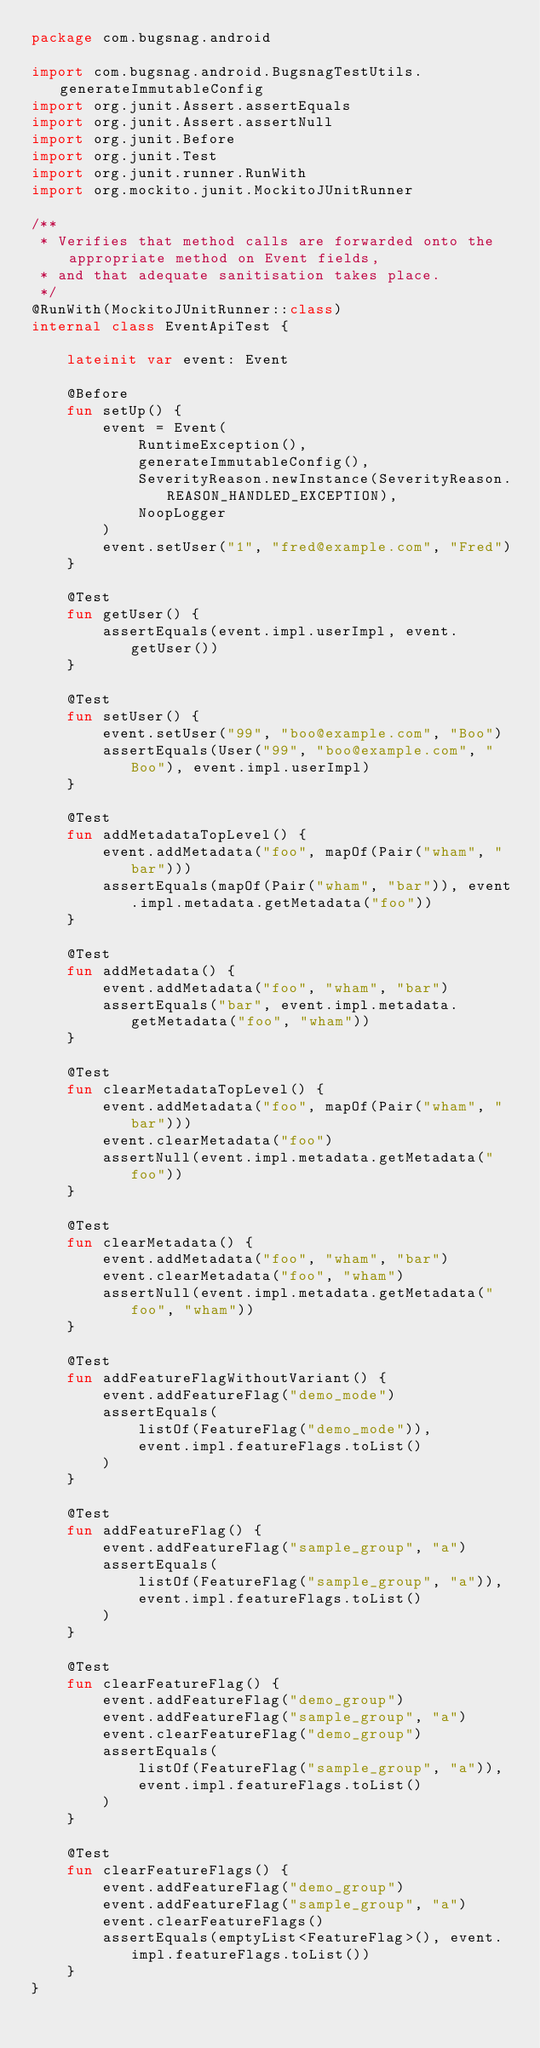<code> <loc_0><loc_0><loc_500><loc_500><_Kotlin_>package com.bugsnag.android

import com.bugsnag.android.BugsnagTestUtils.generateImmutableConfig
import org.junit.Assert.assertEquals
import org.junit.Assert.assertNull
import org.junit.Before
import org.junit.Test
import org.junit.runner.RunWith
import org.mockito.junit.MockitoJUnitRunner

/**
 * Verifies that method calls are forwarded onto the appropriate method on Event fields,
 * and that adequate sanitisation takes place.
 */
@RunWith(MockitoJUnitRunner::class)
internal class EventApiTest {

    lateinit var event: Event

    @Before
    fun setUp() {
        event = Event(
            RuntimeException(),
            generateImmutableConfig(),
            SeverityReason.newInstance(SeverityReason.REASON_HANDLED_EXCEPTION),
            NoopLogger
        )
        event.setUser("1", "fred@example.com", "Fred")
    }

    @Test
    fun getUser() {
        assertEquals(event.impl.userImpl, event.getUser())
    }

    @Test
    fun setUser() {
        event.setUser("99", "boo@example.com", "Boo")
        assertEquals(User("99", "boo@example.com", "Boo"), event.impl.userImpl)
    }

    @Test
    fun addMetadataTopLevel() {
        event.addMetadata("foo", mapOf(Pair("wham", "bar")))
        assertEquals(mapOf(Pair("wham", "bar")), event.impl.metadata.getMetadata("foo"))
    }

    @Test
    fun addMetadata() {
        event.addMetadata("foo", "wham", "bar")
        assertEquals("bar", event.impl.metadata.getMetadata("foo", "wham"))
    }

    @Test
    fun clearMetadataTopLevel() {
        event.addMetadata("foo", mapOf(Pair("wham", "bar")))
        event.clearMetadata("foo")
        assertNull(event.impl.metadata.getMetadata("foo"))
    }

    @Test
    fun clearMetadata() {
        event.addMetadata("foo", "wham", "bar")
        event.clearMetadata("foo", "wham")
        assertNull(event.impl.metadata.getMetadata("foo", "wham"))
    }

    @Test
    fun addFeatureFlagWithoutVariant() {
        event.addFeatureFlag("demo_mode")
        assertEquals(
            listOf(FeatureFlag("demo_mode")),
            event.impl.featureFlags.toList()
        )
    }

    @Test
    fun addFeatureFlag() {
        event.addFeatureFlag("sample_group", "a")
        assertEquals(
            listOf(FeatureFlag("sample_group", "a")),
            event.impl.featureFlags.toList()
        )
    }

    @Test
    fun clearFeatureFlag() {
        event.addFeatureFlag("demo_group")
        event.addFeatureFlag("sample_group", "a")
        event.clearFeatureFlag("demo_group")
        assertEquals(
            listOf(FeatureFlag("sample_group", "a")),
            event.impl.featureFlags.toList()
        )
    }

    @Test
    fun clearFeatureFlags() {
        event.addFeatureFlag("demo_group")
        event.addFeatureFlag("sample_group", "a")
        event.clearFeatureFlags()
        assertEquals(emptyList<FeatureFlag>(), event.impl.featureFlags.toList())
    }
}
</code> 